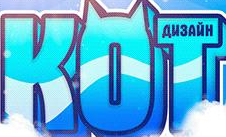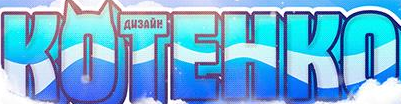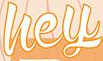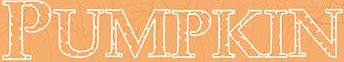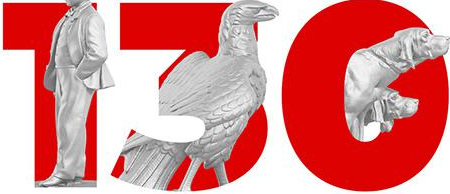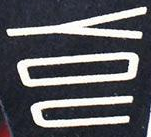Transcribe the words shown in these images in order, separated by a semicolon. KOT; KOTEHKO; hey; PUMPKIN; 130; YOU 